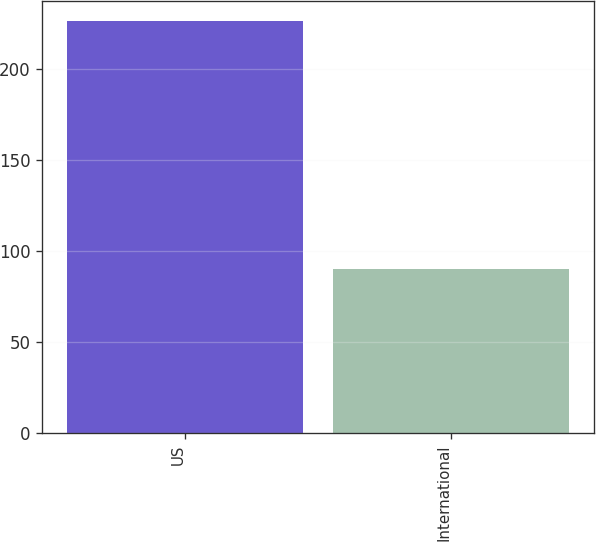Convert chart to OTSL. <chart><loc_0><loc_0><loc_500><loc_500><bar_chart><fcel>US<fcel>International<nl><fcel>226<fcel>90<nl></chart> 